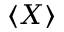<formula> <loc_0><loc_0><loc_500><loc_500>\langle X \rangle</formula> 